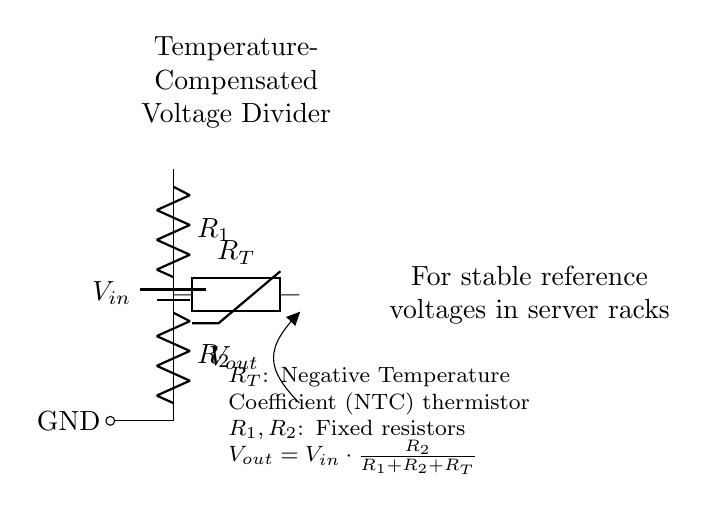What is the input voltage labeled as? The input voltage is labeled as V in, which indicates the voltage supplied to the circuit.
Answer: V in What type of thermistor is used in the circuit? The thermistor is labeled as R T, which stands for a negative temperature coefficient thermistor. This type indicates that resistance decreases with an increase in temperature.
Answer: Negative Temperature Coefficient What formula is used to calculate the output voltage? The output voltage formula provided in the circuit is V out equals V in multiplied by R 2 over the sum of R 1, R 2, and R T. This relationship defines how the voltage divider distributes the input voltage based on resistance values.
Answer: V out = V in * (R 2 / (R 1 + R 2 + R T)) What role does R 1 play in the voltage divider? R 1 acts as one of the resistors in the voltage divider that, along with R 2 and R T, establishes the voltage division ratio to obtain a stable output voltage.
Answer: Resistor in voltage divider How does the thermistor affect the output voltage? The thermistor R T, being a temperature-sensitive resistor, affects the output voltage by altering its resistance with temperature changes, thereby impacting the voltage division and stabilizing output voltage against temperature fluctuations.
Answer: Stabilizes output against temperature changes What is the primary function of this circuit in server racks? The primary function is to maintain stable reference voltages, which are essential for reliable operation of various components in server racks.
Answer: Stable reference voltages 